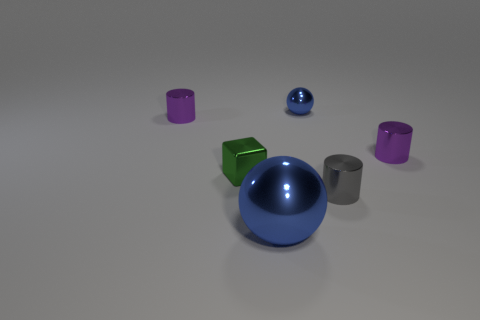Subtract all red balls. Subtract all red cubes. How many balls are left? 2 Add 3 green objects. How many objects exist? 9 Subtract all cubes. How many objects are left? 5 Subtract all tiny metallic cylinders. Subtract all tiny blue things. How many objects are left? 2 Add 1 tiny purple objects. How many tiny purple objects are left? 3 Add 6 blue shiny balls. How many blue shiny balls exist? 8 Subtract 0 green spheres. How many objects are left? 6 